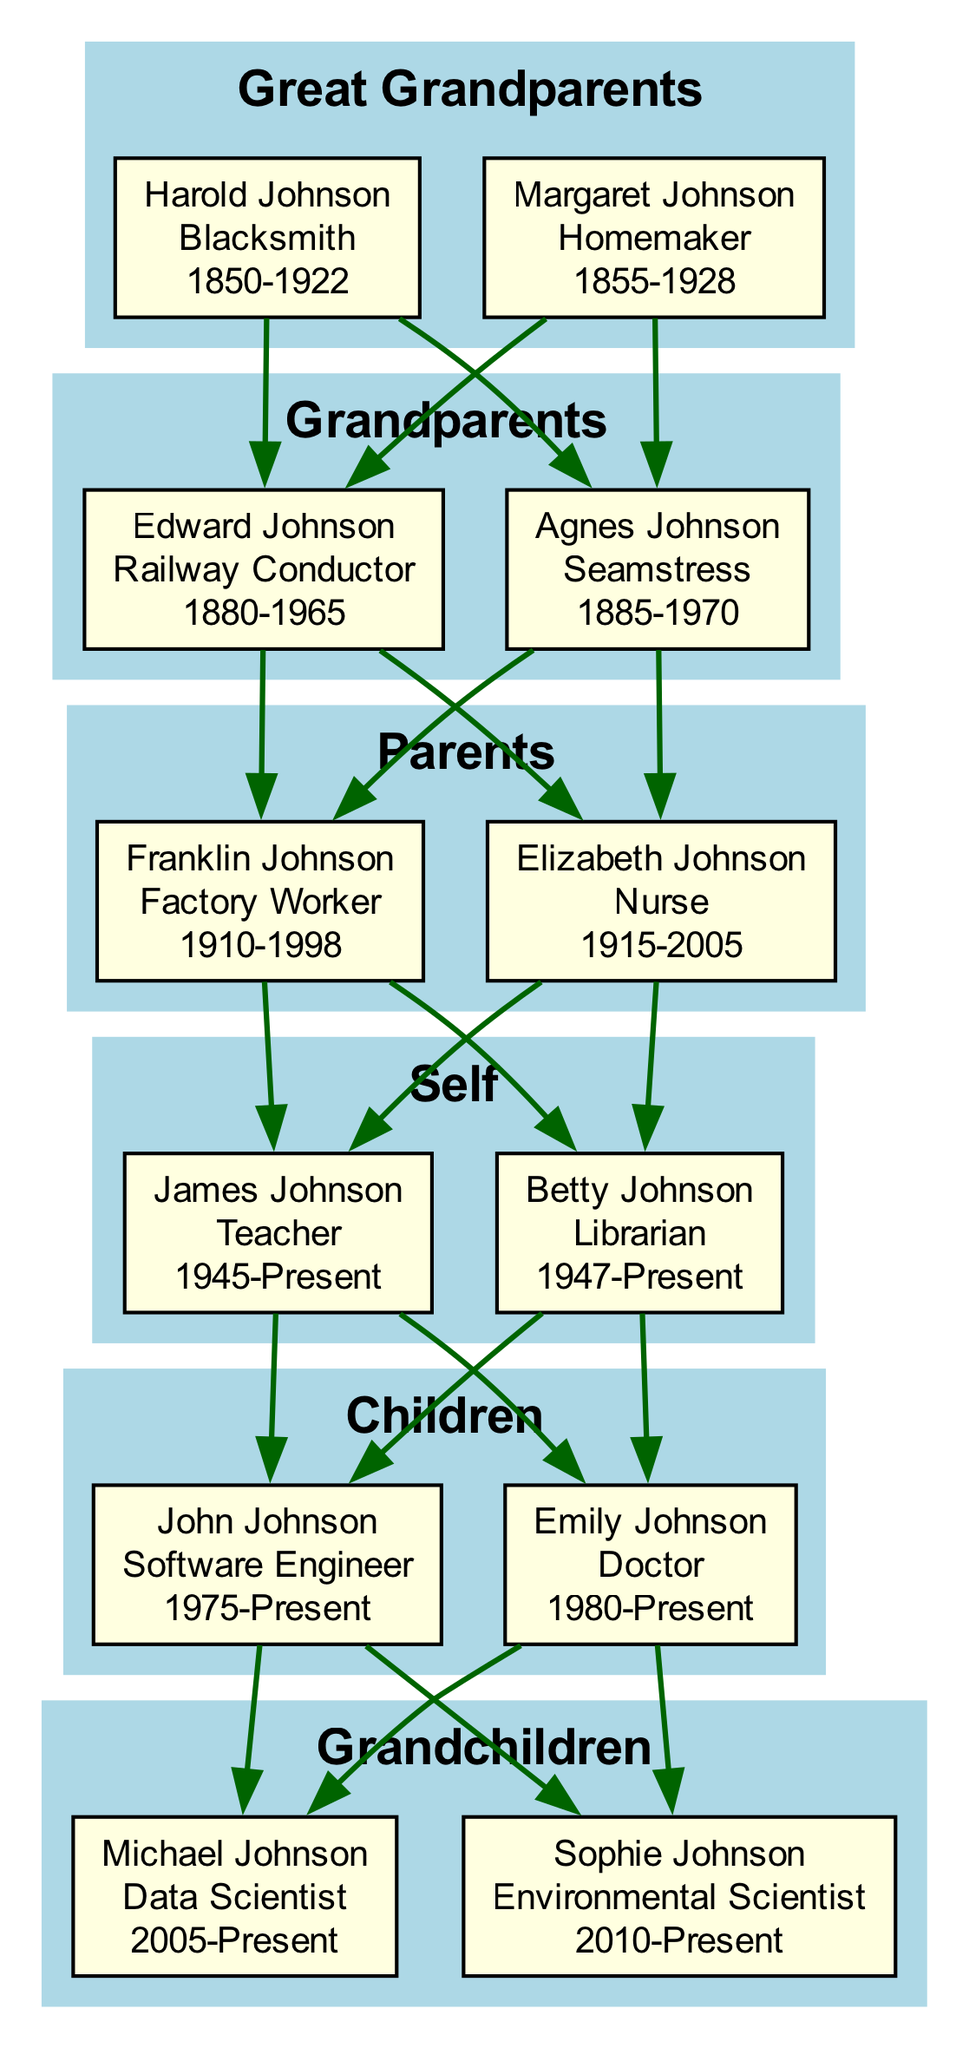What was Harold Johnson's profession? Harold Johnson is listed as a member of the "Great Grandparents" generation, and his profession is indicated as "Blacksmith."
Answer: Blacksmith Who was the seamstress in the family? Agnes Johnson is mentioned in the "Grandparents" generation, and her profession is specified as "Seamstress."
Answer: Agnes Johnson Which generation does Emily Johnson belong to? Emily Johnson is one of the members in the "Children" generation, as indicated in the family tree data.
Answer: Children What profession did Franklin Johnson have? In the "Parents" generation, Franklin Johnson's profession is noted as "Factory Worker."
Answer: Factory Worker How many members are there in the 'Self' generation? The "Self" generation includes two members, James Johnson and Betty Johnson, indicating a total of two members in that generation.
Answer: 2 Which profession shows an evolution from the 'Self' to the 'Children' generation in the family? The profession "Teacher" from James Johnson in the "Self" generation can be reasoned to have evolved to "Doctor" for Emily Johnson in the "Children" generation, indicating a shift toward professional occupations.
Answer: Teacher to Doctor How many generations between the Great Grandparents and Grandchildren? Counting from Great Grandparents to Grandchildren inclusively: Great Grandparents, Grandparents, Parents, Self, Children, and Grandchildren results in a total of five generations.
Answer: 5 What is the youngest profession in the family tree? Michael Johnson, born in 2005, has the profession of "Data Scientist," which is the most recent occupation listed in the family tree.
Answer: Data Scientist Which profession did the eldest Johnson (Harold) have? Harold Johnson is noted as the oldest in the family tree and is listed with the profession "Blacksmith."
Answer: Blacksmith 